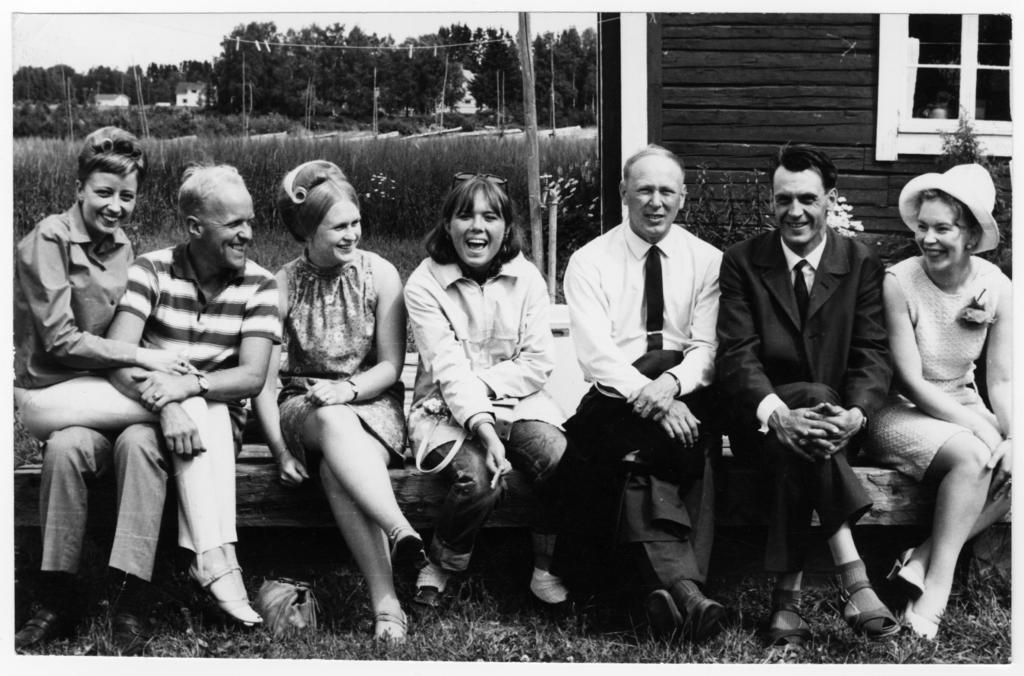What type of picture is the image? The image is an old black and white picture. What are the people in the image doing? There is a group of people sitting on a bench in the image. What can be seen behind the people in the image? Plants, houses, and trees are visible behind the people in the image. What is visible in the background of the image? The sky is visible in the background of the image. What is the taste of the bed in the image? There is no bed present in the image, so it is not possible to determine its taste. 